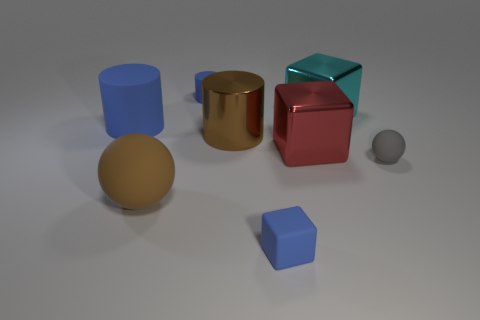Subtract all big red metal blocks. How many blocks are left? 2 Subtract 3 cylinders. How many cylinders are left? 0 Add 2 big red metallic blocks. How many objects exist? 10 Subtract all cyan blocks. How many blocks are left? 2 Subtract all tiny gray matte objects. Subtract all big matte objects. How many objects are left? 5 Add 7 cyan cubes. How many cyan cubes are left? 8 Add 8 small blue matte spheres. How many small blue matte spheres exist? 8 Subtract 0 gray cylinders. How many objects are left? 8 Subtract all cylinders. How many objects are left? 5 Subtract all brown cubes. Subtract all red cylinders. How many cubes are left? 3 